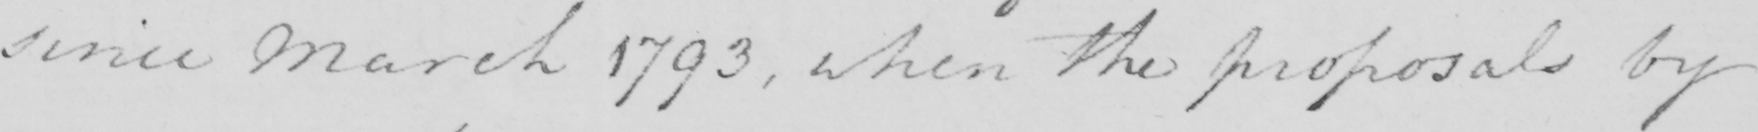What is written in this line of handwriting? since March 1793 , when the proposals by 